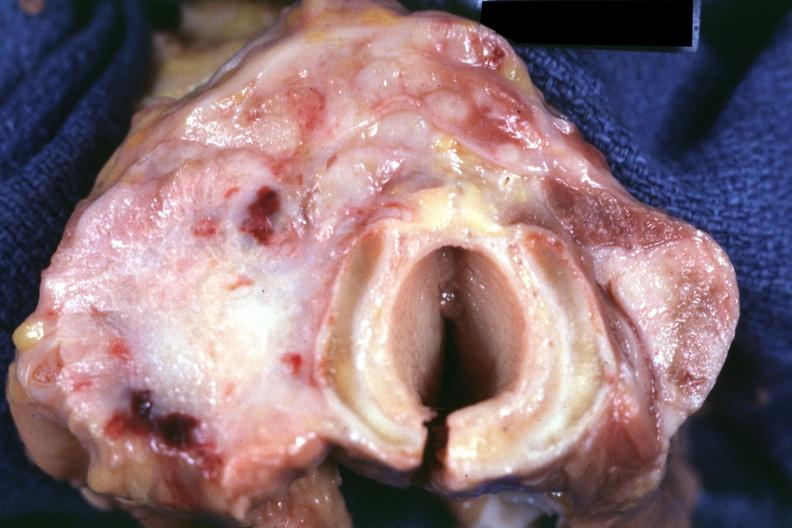s thyroid present?
Answer the question using a single word or phrase. Yes 